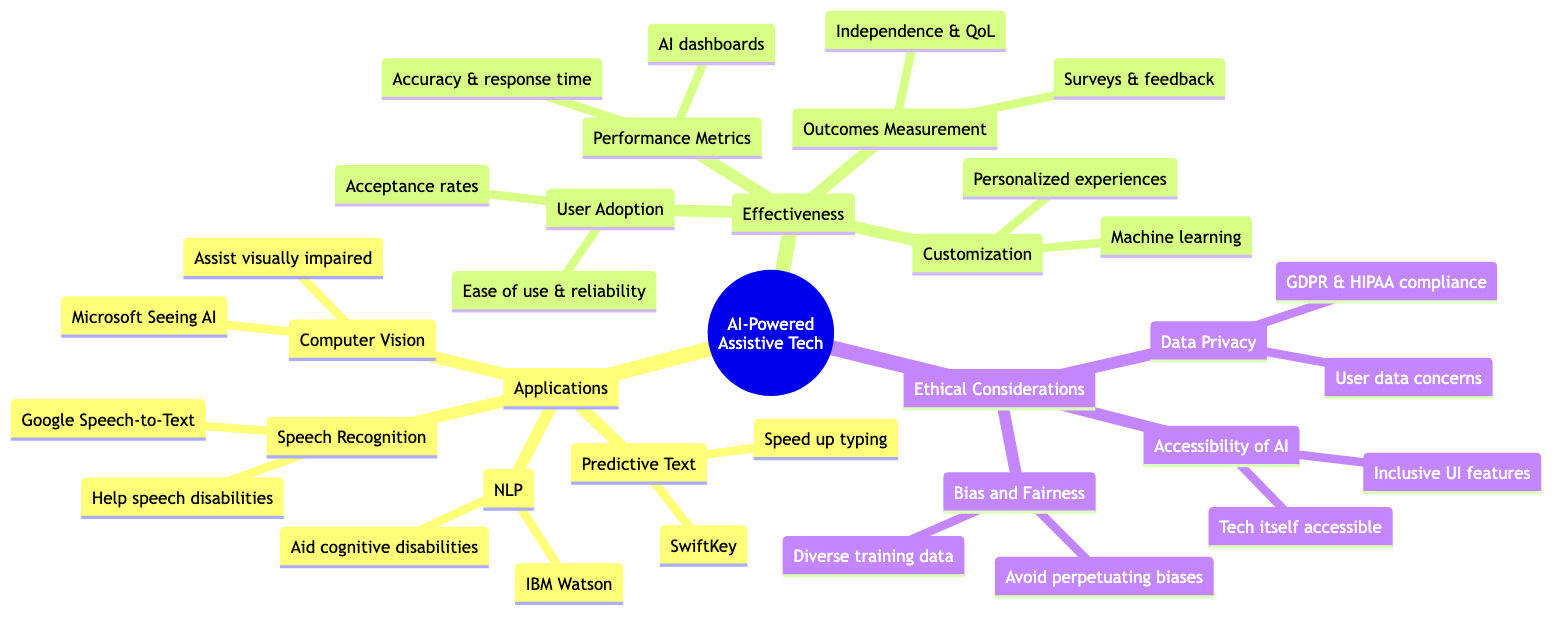What is an application of AI in assistive technologies? The diagram lists several applications under the "Applications" category. One example is "Speech Recognition Systems," which corresponds to Google's Speech-to-Text.
Answer: Speech Recognition Systems How many applications are mentioned in the diagram? The diagram contains a single category for "Applications" with four specific applications listed: Speech Recognition Systems, Computer Vision for Accessibility, Natural Language Processing, and Predictive Text and Autocomplete. Counting these gives a total of four applications.
Answer: 4 What tools are used for outcomes measurement? Under the "Effectiveness" section, "Outcomes Measurement" explicitly mentions using "Standardized surveys and personal feedback systems" to gauge effectiveness.
Answer: Standardized surveys and personal feedback systems What is the main concern regarding data privacy listed in the diagram? The "Data Privacy" sub-point in the "Ethical Considerations" section states that the concern pertains to "User data being collected."
Answer: User data being collected Which application aims to assist visually impaired users? The "Computer Vision for Accessibility" under "Applications" mentions using "Microsoft's Seeing AI" to assist visually impaired users in navigating and understanding their environment.
Answer: Computer Vision for Accessibility What is one of the effectiveness metrics mentioned in the diagram? In the "Effectiveness" section, "Performance Metrics" indicates tracking "accuracy, response time, and user satisfaction" as important effectiveness metrics.
Answer: Accuracy, response time, and user satisfaction What does “Customization and Personalization” leverage to improve experiences? The diagram indicates that "Customization and Personalization" uses "machine learning" to tailor experiences to users, suggesting that advanced algorithms are implemented for user-specific adjustments.
Answer: Machine learning What compliance regulations are noted in relation to data privacy? In the "Data Privacy" subsection under "Ethical Considerations," it mentions compliance with "GDPR, HIPAA," indicating the standards that organizations must adhere to for data protection.
Answer: GDPR, HIPAA 